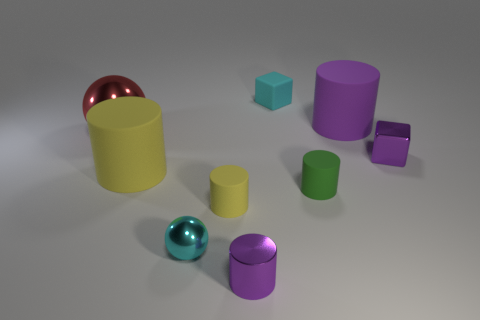Subtract 1 cylinders. How many cylinders are left? 4 Subtract all small purple cylinders. How many cylinders are left? 4 Subtract all green cylinders. How many cylinders are left? 4 Add 1 cyan shiny things. How many objects exist? 10 Subtract all green cylinders. Subtract all blue cubes. How many cylinders are left? 4 Subtract all spheres. How many objects are left? 7 Subtract all cylinders. Subtract all tiny matte things. How many objects are left? 1 Add 2 large rubber cylinders. How many large rubber cylinders are left? 4 Add 3 tiny yellow metal blocks. How many tiny yellow metal blocks exist? 3 Subtract 1 purple blocks. How many objects are left? 8 